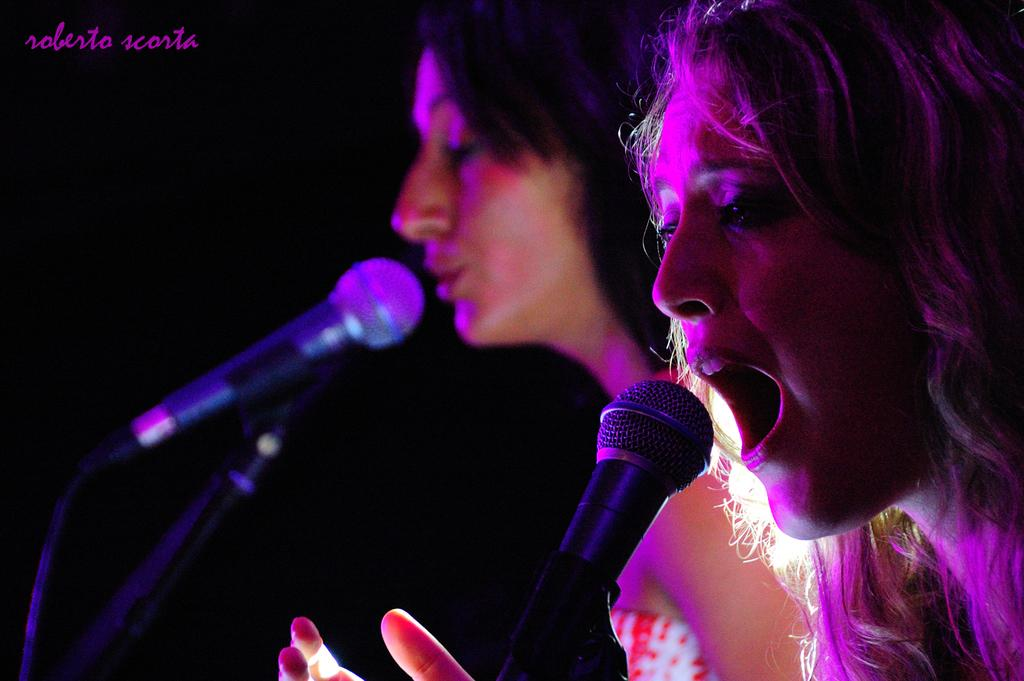Who is present in the image? There are women in the image. Where are the women located in the image? The women are on the right side of the image. What objects are in front of the women? There are microphones in front of the women. What is the woman in the front doing? The woman in the front is singing. What type of shoes are the women wearing in the image? The provided facts do not mention any shoes, so we cannot determine what type of shoes the women are wearing. 